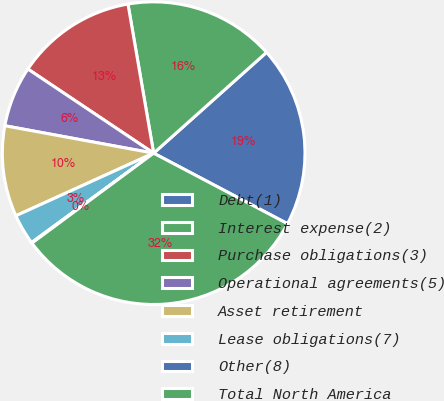Convert chart. <chart><loc_0><loc_0><loc_500><loc_500><pie_chart><fcel>Debt(1)<fcel>Interest expense(2)<fcel>Purchase obligations(3)<fcel>Operational agreements(5)<fcel>Asset retirement<fcel>Lease obligations(7)<fcel>Other(8)<fcel>Total North America<nl><fcel>19.32%<fcel>16.11%<fcel>12.9%<fcel>6.48%<fcel>9.69%<fcel>3.27%<fcel>0.07%<fcel>32.15%<nl></chart> 